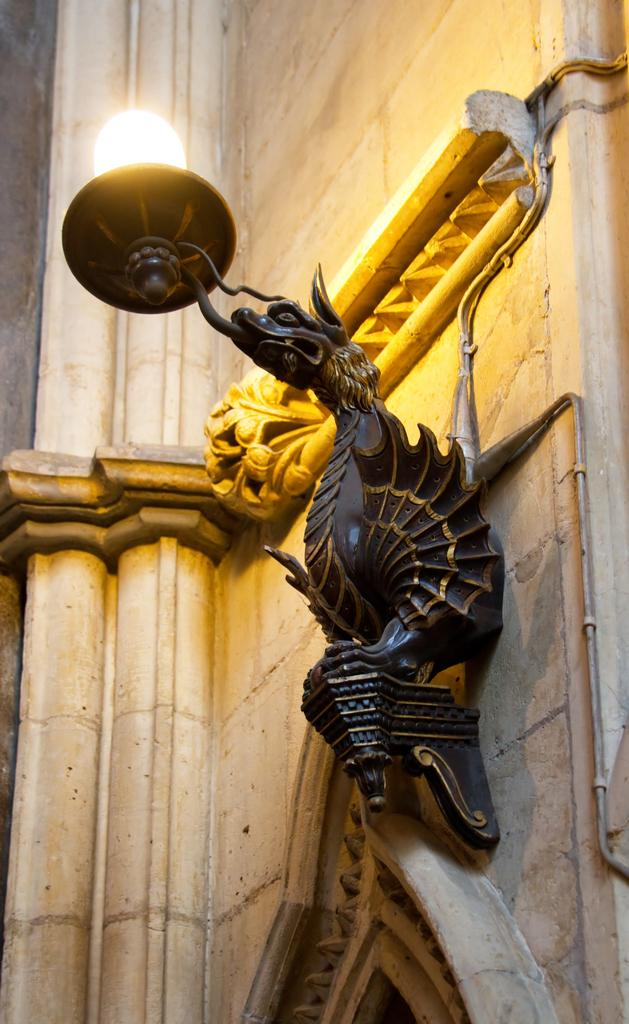What is the main object in the foreground of the image? There is a lamp light in the foreground of the image. How is the lamp light positioned in the image? The lamp light is attached to a wall. What architectural feature can be seen at the bottom of the image? There appears to be an arch at the bottom of the image. How many beans are visible on the lamp light in the image? There are no beans present on the lamp light in the image. What type of rat can be seen interacting with the lamp light in the image? There is no rat present in the image; the lamp light is attached to a wall. 